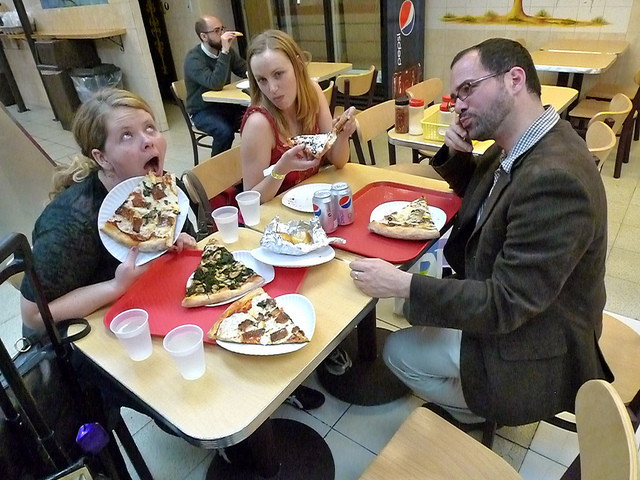How does the mood of the people in the image seem to you? The mood appears jovial and expressive; one person shows a particularly animated expression of surprise or delight, while the others seem content and engaged in their meal. 